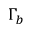<formula> <loc_0><loc_0><loc_500><loc_500>\Gamma _ { b }</formula> 